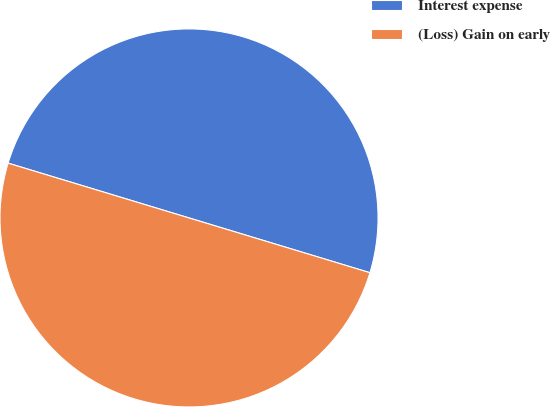Convert chart to OTSL. <chart><loc_0><loc_0><loc_500><loc_500><pie_chart><fcel>Interest expense<fcel>(Loss) Gain on early<nl><fcel>50.0%<fcel>50.0%<nl></chart> 